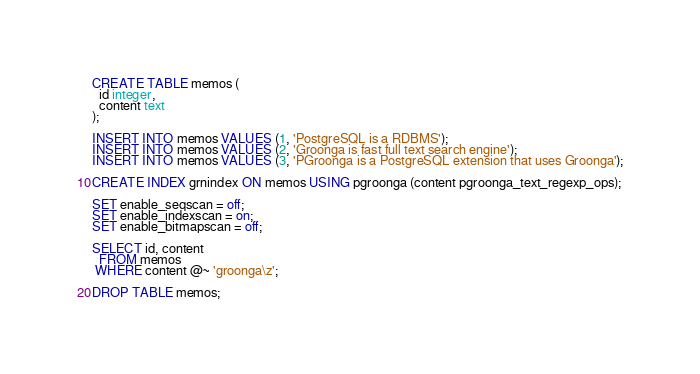<code> <loc_0><loc_0><loc_500><loc_500><_SQL_>CREATE TABLE memos (
  id integer,
  content text
);

INSERT INTO memos VALUES (1, 'PostgreSQL is a RDBMS');
INSERT INTO memos VALUES (2, 'Groonga is fast full text search engine');
INSERT INTO memos VALUES (3, 'PGroonga is a PostgreSQL extension that uses Groonga');

CREATE INDEX grnindex ON memos USING pgroonga (content pgroonga_text_regexp_ops);

SET enable_seqscan = off;
SET enable_indexscan = on;
SET enable_bitmapscan = off;

SELECT id, content
  FROM memos
 WHERE content @~ 'groonga\z';

DROP TABLE memos;
</code> 